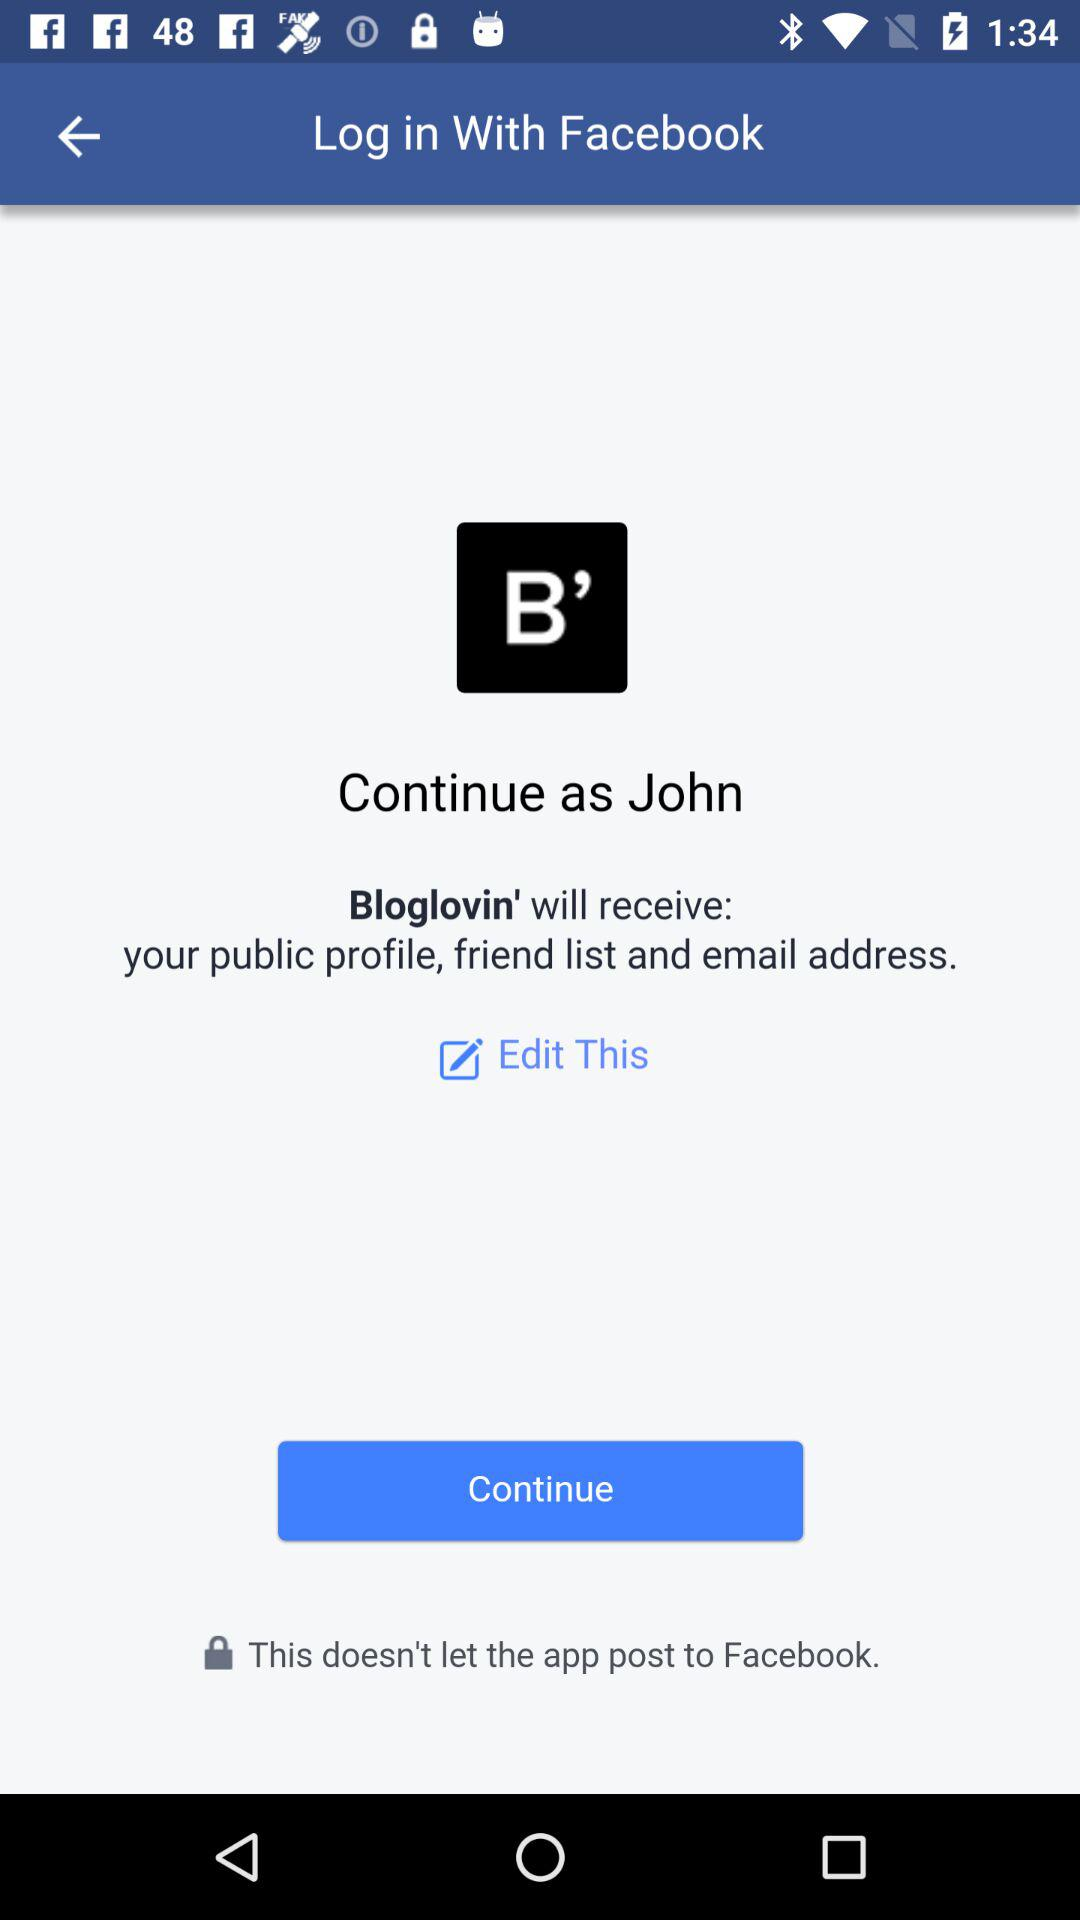Which option is selected?
When the provided information is insufficient, respond with <no answer>. <no answer> 